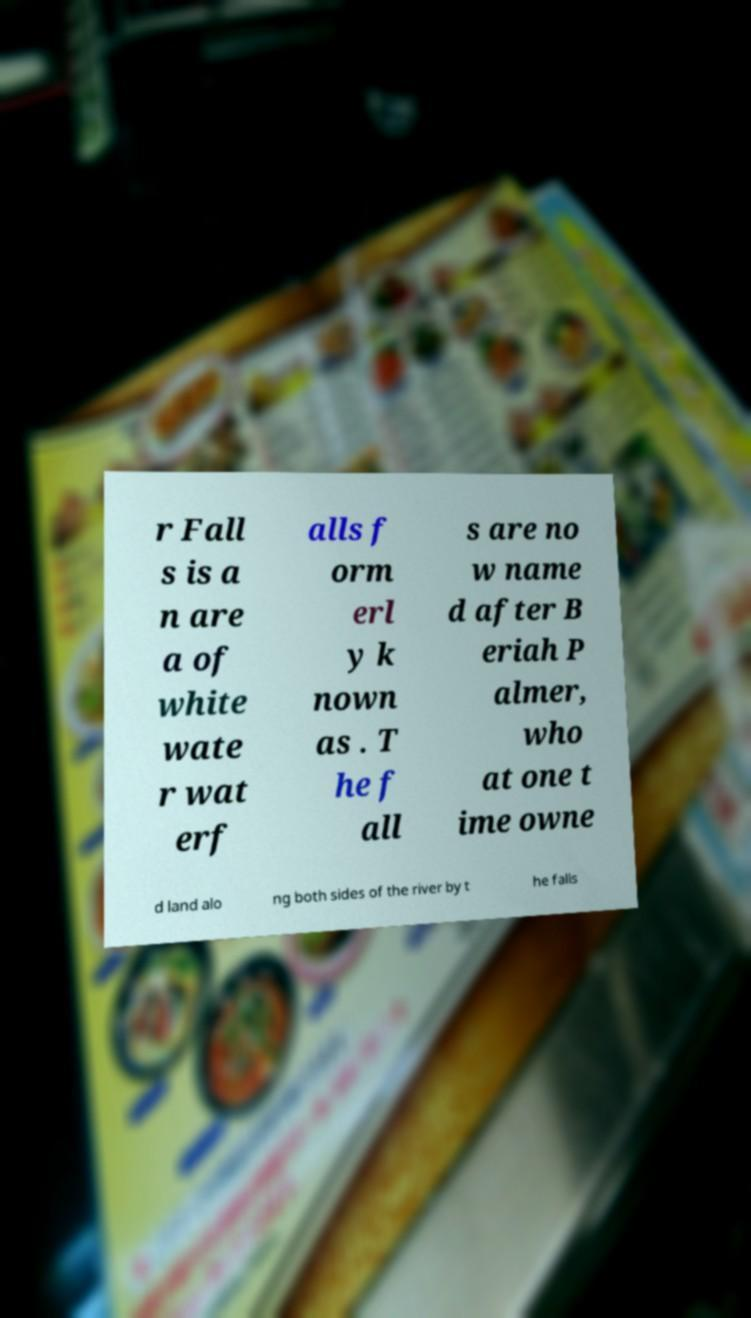What messages or text are displayed in this image? I need them in a readable, typed format. r Fall s is a n are a of white wate r wat erf alls f orm erl y k nown as . T he f all s are no w name d after B eriah P almer, who at one t ime owne d land alo ng both sides of the river by t he falls 